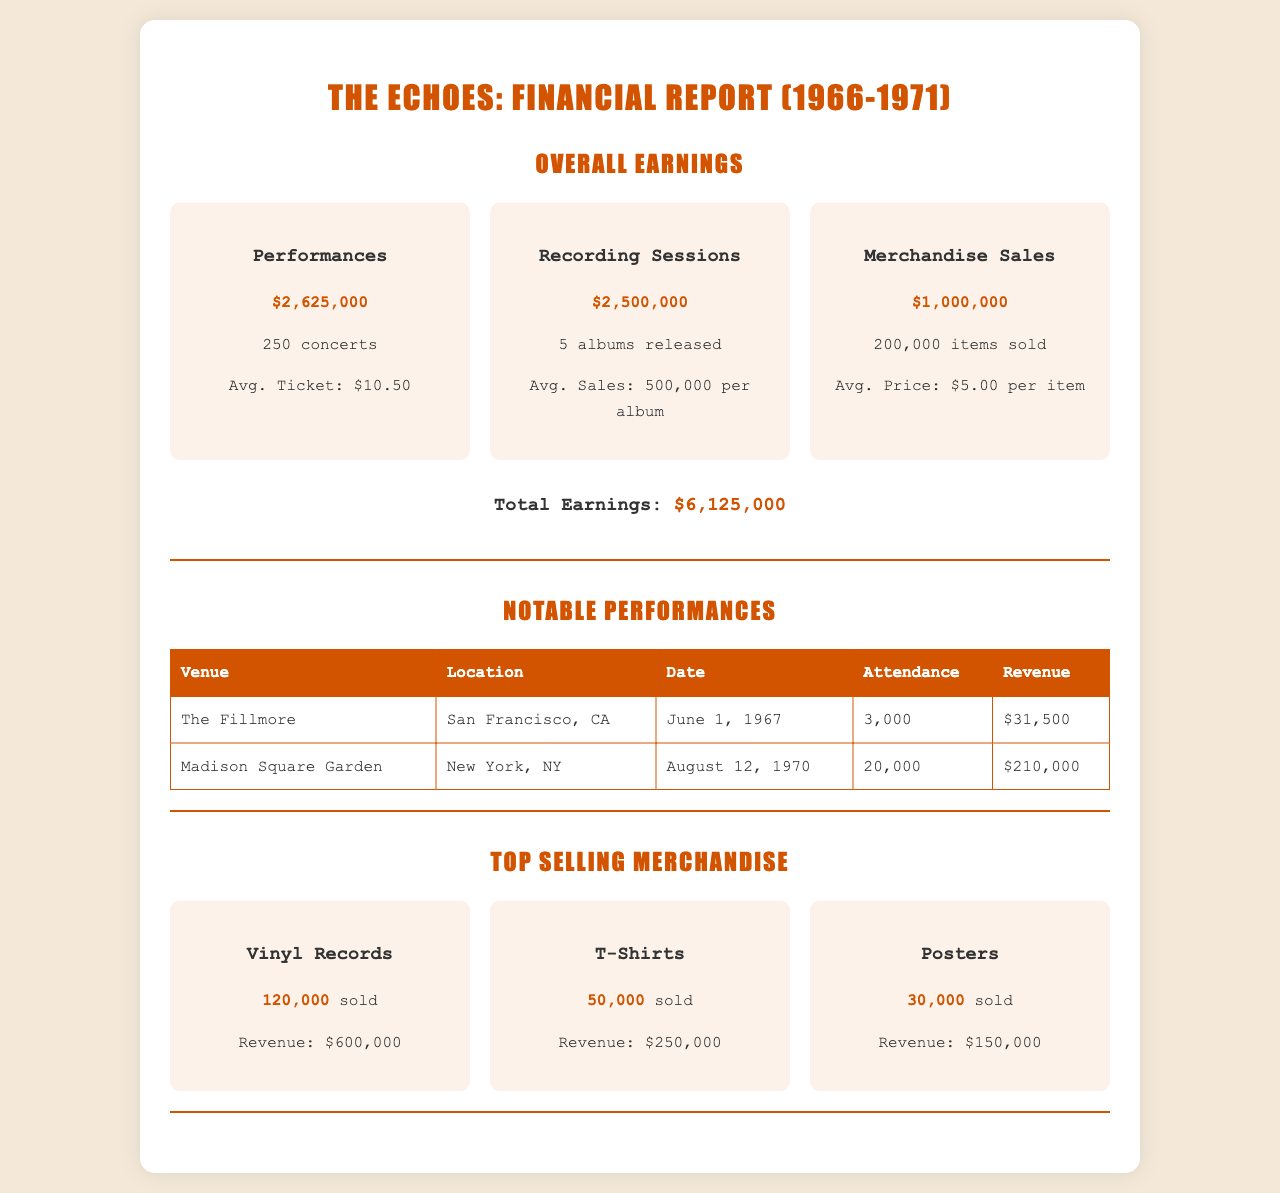What were the total earnings during the peak touring years? The total earnings are provided in the document as the sum of performances, recording sessions, and merchandise sales, which amounts to $6,125,000.
Answer: $6,125,000 How many concerts did the band perform? The document specifies that the band performed a total of 250 concerts.
Answer: 250 concerts What was the average ticket price? The average ticket price is mentioned as $10.50 for performances.
Answer: $10.50 How many albums did they release during this period? The document states that the band released 5 albums during the specified years.
Answer: 5 albums What is the revenue generated from merchandise sales? The revenue from merchandise sales is provided as $1,000,000.
Answer: $1,000,000 Which venue had the highest attendance? The document lists Madison Square Garden with an attendance of 20,000 as the venue with the highest attendance.
Answer: Madison Square Garden What was the revenue for the concert at The Fillmore? The revenue for the concert held at The Fillmore is recorded as $31,500.
Answer: $31,500 How many vinyl records were sold? According to the document, 120,000 vinyl records were sold, which is the highest among merchandise items.
Answer: 120,000 What is the total revenue from T-shirts? The revenue generated from T-shirts is mentioned as $250,000 in the merchandise section.
Answer: $250,000 